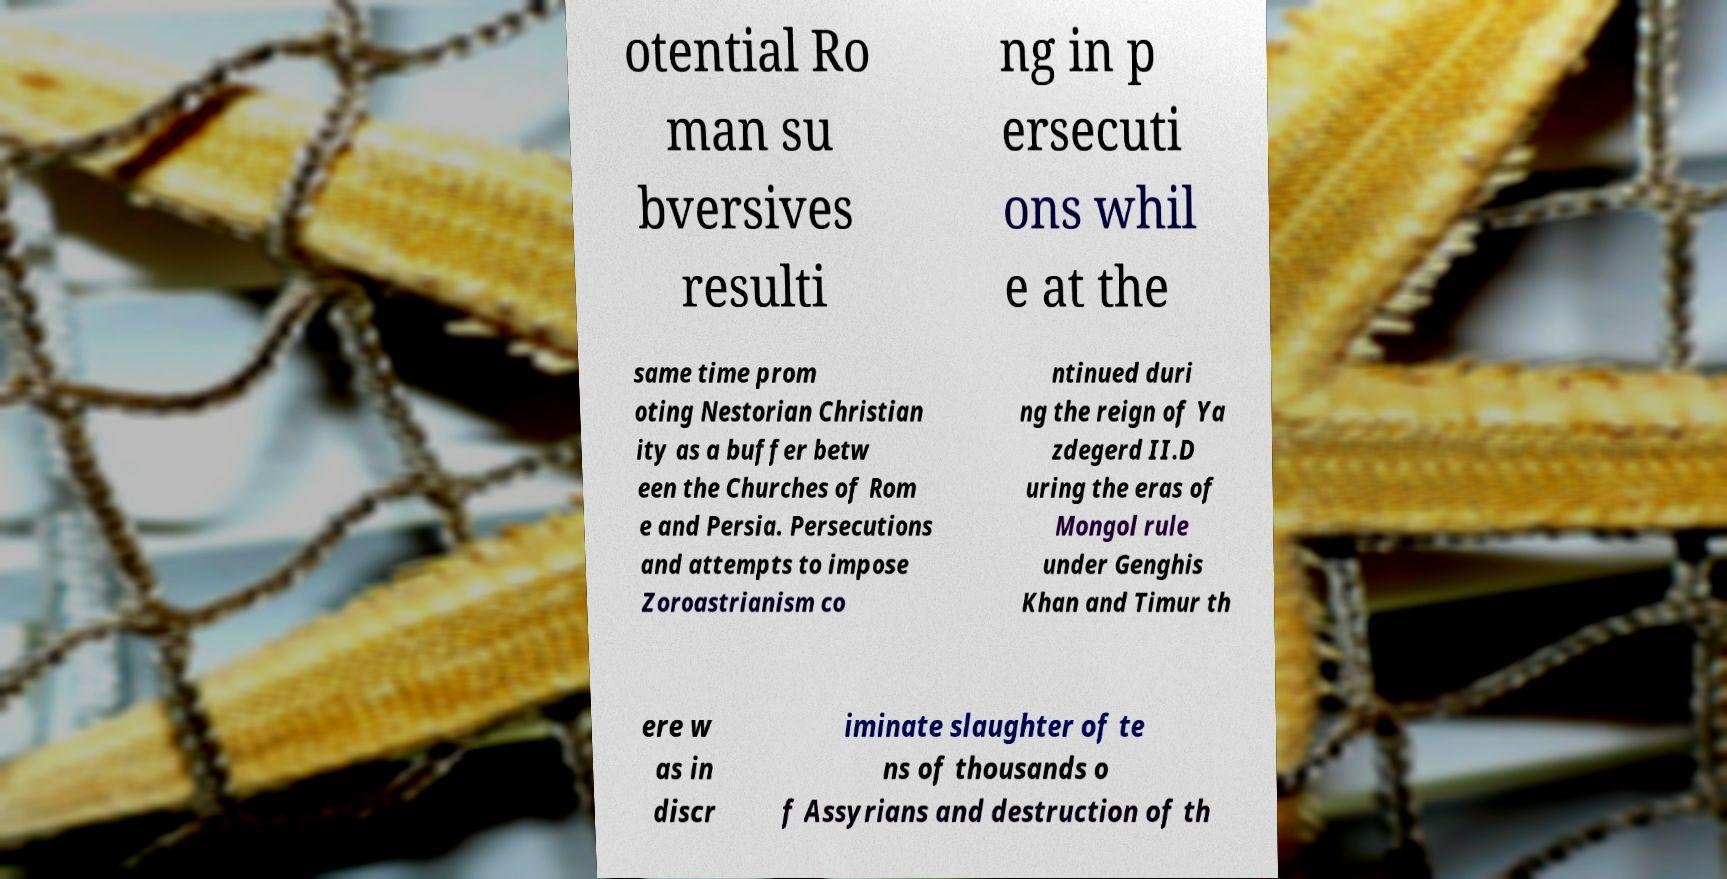Can you accurately transcribe the text from the provided image for me? otential Ro man su bversives resulti ng in p ersecuti ons whil e at the same time prom oting Nestorian Christian ity as a buffer betw een the Churches of Rom e and Persia. Persecutions and attempts to impose Zoroastrianism co ntinued duri ng the reign of Ya zdegerd II.D uring the eras of Mongol rule under Genghis Khan and Timur th ere w as in discr iminate slaughter of te ns of thousands o f Assyrians and destruction of th 